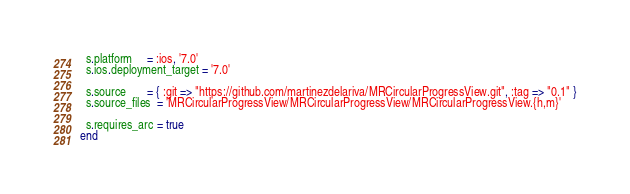<code> <loc_0><loc_0><loc_500><loc_500><_Ruby_>
  s.platform     = :ios, '7.0'
  s.ios.deployment_target = '7.0'

  s.source       = { :git => "https://github.com/martinezdelariva/MRCircularProgressView.git", :tag => "0.1" }
  s.source_files  = 'MRCircularProgressView/MRCircularProgressView/MRCircularProgressView.{h,m}'

  s.requires_arc = true
end
</code> 